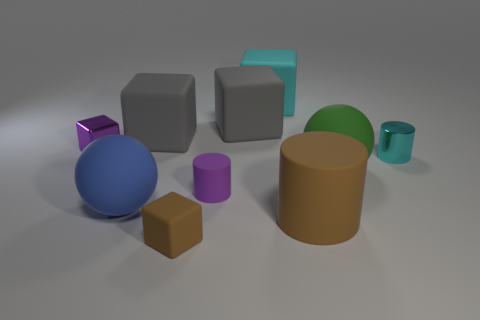Subtract 2 cubes. How many cubes are left? 3 Subtract all purple blocks. How many blocks are left? 4 Subtract all cyan rubber blocks. How many blocks are left? 4 Subtract all red blocks. Subtract all yellow cylinders. How many blocks are left? 5 Subtract all cylinders. How many objects are left? 7 Add 3 small shiny objects. How many small shiny objects are left? 5 Add 2 yellow metal things. How many yellow metal things exist? 2 Subtract 1 purple cylinders. How many objects are left? 9 Subtract all metal cubes. Subtract all big gray rubber things. How many objects are left? 7 